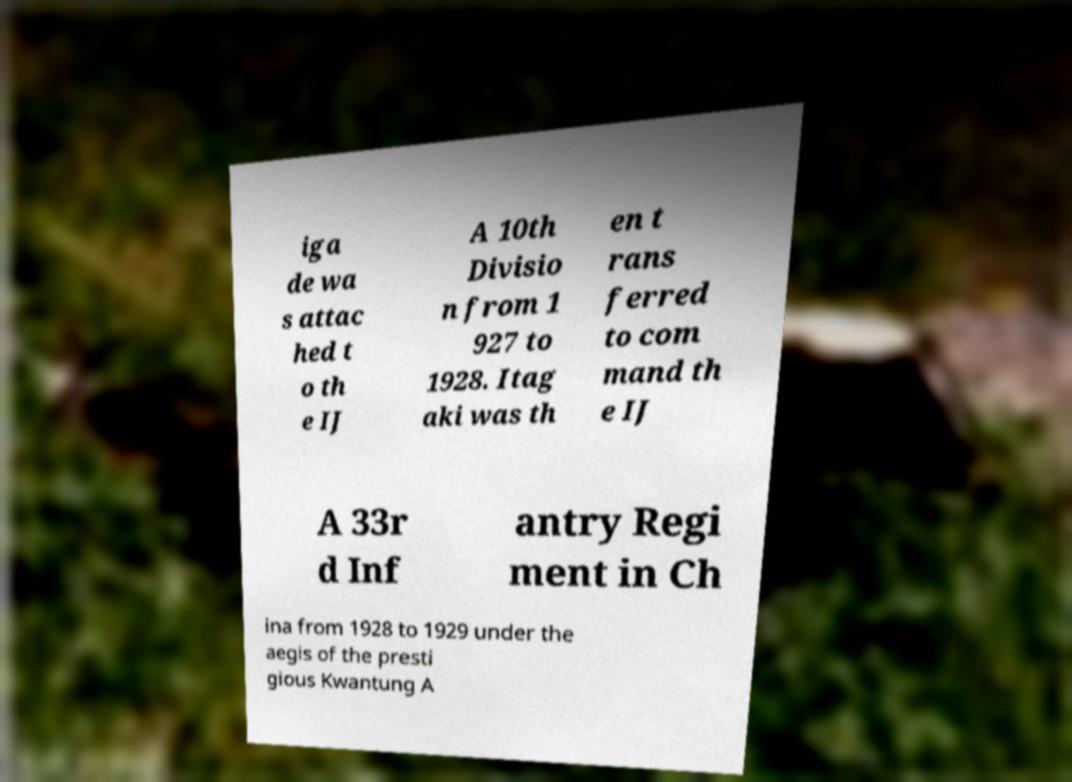What messages or text are displayed in this image? I need them in a readable, typed format. iga de wa s attac hed t o th e IJ A 10th Divisio n from 1 927 to 1928. Itag aki was th en t rans ferred to com mand th e IJ A 33r d Inf antry Regi ment in Ch ina from 1928 to 1929 under the aegis of the presti gious Kwantung A 